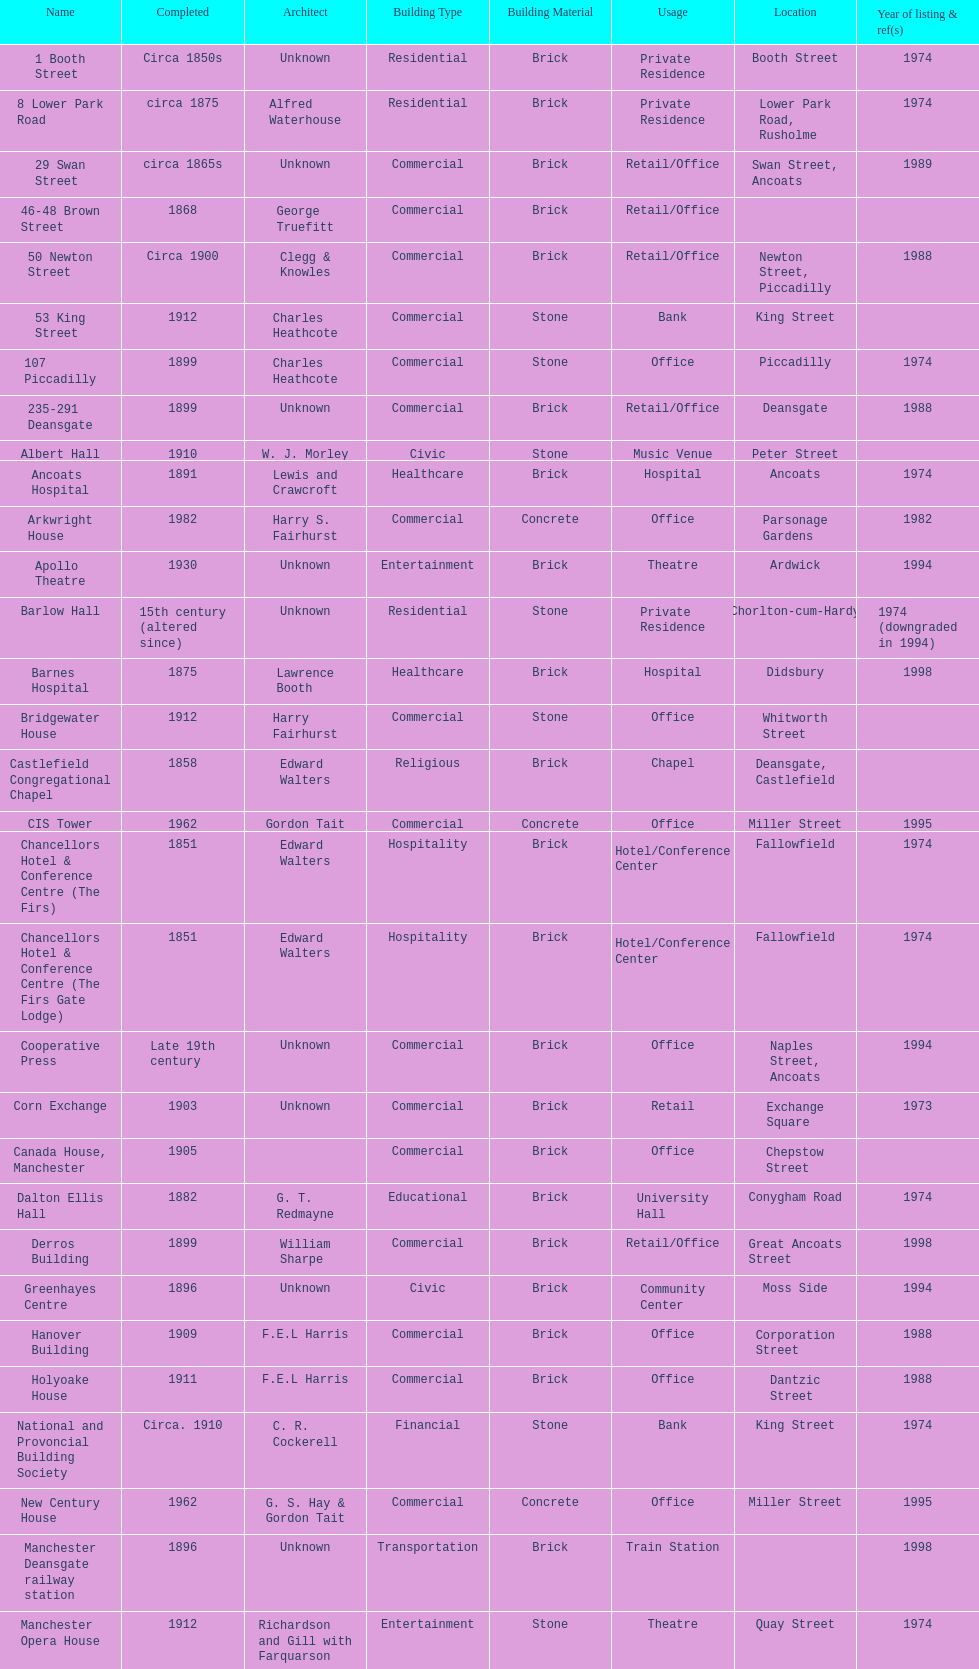How many buildings had alfred waterhouse as their architect? 3. 